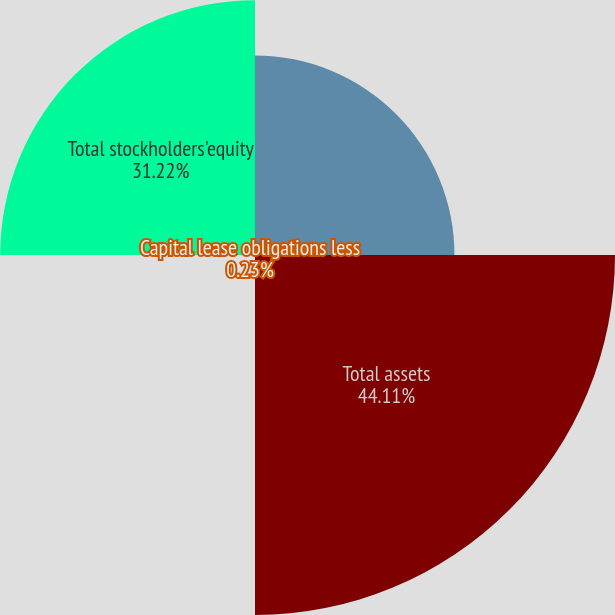Convert chart to OTSL. <chart><loc_0><loc_0><loc_500><loc_500><pie_chart><fcel>Cash cash equivalents and<fcel>Total assets<fcel>Capital lease obligations less<fcel>Total stockholders'equity<nl><fcel>24.44%<fcel>44.11%<fcel>0.23%<fcel>31.22%<nl></chart> 